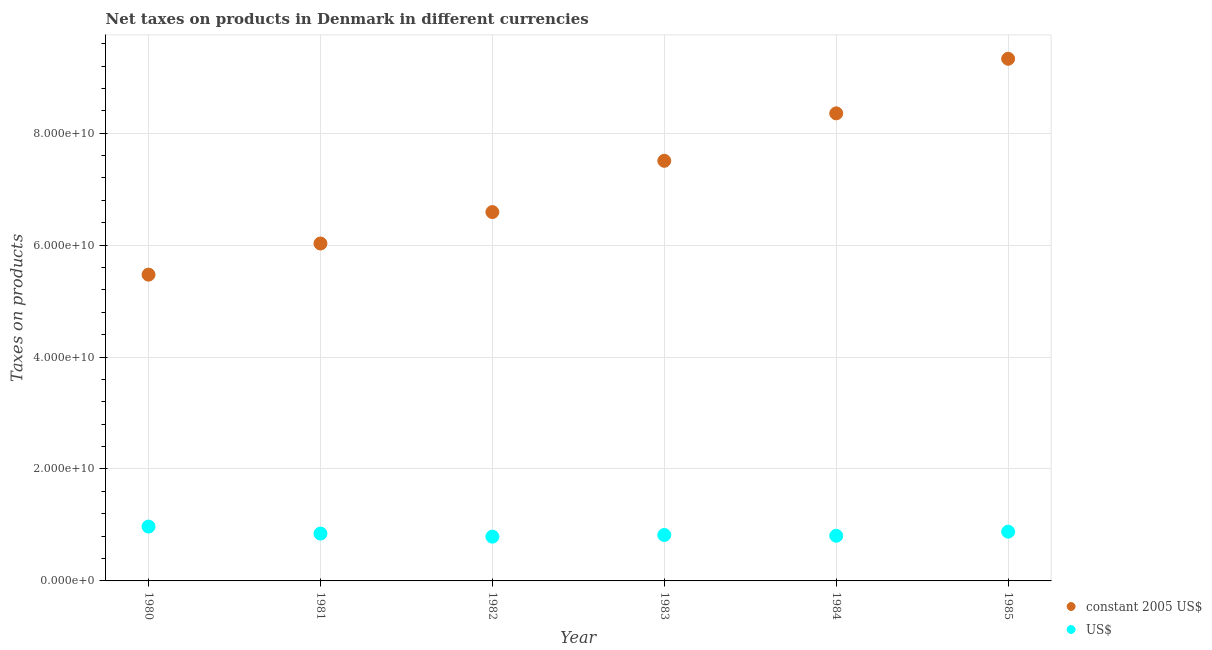How many different coloured dotlines are there?
Ensure brevity in your answer.  2. What is the net taxes in constant 2005 us$ in 1981?
Provide a succinct answer. 6.03e+1. Across all years, what is the maximum net taxes in us$?
Your answer should be very brief. 9.71e+09. Across all years, what is the minimum net taxes in constant 2005 us$?
Make the answer very short. 5.47e+1. In which year was the net taxes in constant 2005 us$ minimum?
Ensure brevity in your answer.  1980. What is the total net taxes in us$ in the graph?
Provide a succinct answer. 5.12e+1. What is the difference between the net taxes in constant 2005 us$ in 1980 and that in 1982?
Offer a very short reply. -1.12e+1. What is the difference between the net taxes in us$ in 1982 and the net taxes in constant 2005 us$ in 1983?
Keep it short and to the point. -6.72e+1. What is the average net taxes in constant 2005 us$ per year?
Ensure brevity in your answer.  7.21e+1. In the year 1985, what is the difference between the net taxes in us$ and net taxes in constant 2005 us$?
Your response must be concise. -8.45e+1. What is the ratio of the net taxes in constant 2005 us$ in 1980 to that in 1981?
Offer a very short reply. 0.91. Is the difference between the net taxes in constant 2005 us$ in 1983 and 1985 greater than the difference between the net taxes in us$ in 1983 and 1985?
Your response must be concise. No. What is the difference between the highest and the second highest net taxes in constant 2005 us$?
Make the answer very short. 9.75e+09. What is the difference between the highest and the lowest net taxes in constant 2005 us$?
Offer a very short reply. 3.86e+1. Is the sum of the net taxes in constant 2005 us$ in 1981 and 1983 greater than the maximum net taxes in us$ across all years?
Your answer should be very brief. Yes. Is the net taxes in constant 2005 us$ strictly greater than the net taxes in us$ over the years?
Provide a short and direct response. Yes. How many years are there in the graph?
Keep it short and to the point. 6. What is the difference between two consecutive major ticks on the Y-axis?
Offer a very short reply. 2.00e+1. Are the values on the major ticks of Y-axis written in scientific E-notation?
Give a very brief answer. Yes. Does the graph contain any zero values?
Your answer should be compact. No. How many legend labels are there?
Make the answer very short. 2. How are the legend labels stacked?
Offer a terse response. Vertical. What is the title of the graph?
Offer a terse response. Net taxes on products in Denmark in different currencies. Does "Urban agglomerations" appear as one of the legend labels in the graph?
Your answer should be very brief. No. What is the label or title of the Y-axis?
Your answer should be very brief. Taxes on products. What is the Taxes on products of constant 2005 US$ in 1980?
Keep it short and to the point. 5.47e+1. What is the Taxes on products in US$ in 1980?
Keep it short and to the point. 9.71e+09. What is the Taxes on products in constant 2005 US$ in 1981?
Ensure brevity in your answer.  6.03e+1. What is the Taxes on products in US$ in 1981?
Provide a succinct answer. 8.46e+09. What is the Taxes on products in constant 2005 US$ in 1982?
Offer a very short reply. 6.59e+1. What is the Taxes on products of US$ in 1982?
Your answer should be compact. 7.91e+09. What is the Taxes on products in constant 2005 US$ in 1983?
Ensure brevity in your answer.  7.51e+1. What is the Taxes on products of US$ in 1983?
Your answer should be very brief. 8.21e+09. What is the Taxes on products of constant 2005 US$ in 1984?
Keep it short and to the point. 8.35e+1. What is the Taxes on products of US$ in 1984?
Keep it short and to the point. 8.07e+09. What is the Taxes on products in constant 2005 US$ in 1985?
Ensure brevity in your answer.  9.33e+1. What is the Taxes on products in US$ in 1985?
Ensure brevity in your answer.  8.80e+09. Across all years, what is the maximum Taxes on products in constant 2005 US$?
Your response must be concise. 9.33e+1. Across all years, what is the maximum Taxes on products of US$?
Keep it short and to the point. 9.71e+09. Across all years, what is the minimum Taxes on products in constant 2005 US$?
Offer a terse response. 5.47e+1. Across all years, what is the minimum Taxes on products in US$?
Make the answer very short. 7.91e+09. What is the total Taxes on products of constant 2005 US$ in the graph?
Your answer should be very brief. 4.33e+11. What is the total Taxes on products in US$ in the graph?
Offer a terse response. 5.12e+1. What is the difference between the Taxes on products in constant 2005 US$ in 1980 and that in 1981?
Give a very brief answer. -5.56e+09. What is the difference between the Taxes on products of US$ in 1980 and that in 1981?
Provide a short and direct response. 1.25e+09. What is the difference between the Taxes on products of constant 2005 US$ in 1980 and that in 1982?
Make the answer very short. -1.12e+1. What is the difference between the Taxes on products of US$ in 1980 and that in 1982?
Your answer should be compact. 1.80e+09. What is the difference between the Taxes on products of constant 2005 US$ in 1980 and that in 1983?
Your answer should be compact. -2.03e+1. What is the difference between the Taxes on products in US$ in 1980 and that in 1983?
Offer a very short reply. 1.50e+09. What is the difference between the Taxes on products of constant 2005 US$ in 1980 and that in 1984?
Make the answer very short. -2.88e+1. What is the difference between the Taxes on products in US$ in 1980 and that in 1984?
Make the answer very short. 1.64e+09. What is the difference between the Taxes on products in constant 2005 US$ in 1980 and that in 1985?
Make the answer very short. -3.86e+1. What is the difference between the Taxes on products in US$ in 1980 and that in 1985?
Keep it short and to the point. 9.06e+08. What is the difference between the Taxes on products of constant 2005 US$ in 1981 and that in 1982?
Your answer should be very brief. -5.62e+09. What is the difference between the Taxes on products in US$ in 1981 and that in 1982?
Offer a terse response. 5.54e+08. What is the difference between the Taxes on products of constant 2005 US$ in 1981 and that in 1983?
Provide a succinct answer. -1.48e+1. What is the difference between the Taxes on products in US$ in 1981 and that in 1983?
Make the answer very short. 2.55e+08. What is the difference between the Taxes on products of constant 2005 US$ in 1981 and that in 1984?
Your answer should be compact. -2.33e+1. What is the difference between the Taxes on products of US$ in 1981 and that in 1984?
Ensure brevity in your answer.  3.97e+08. What is the difference between the Taxes on products in constant 2005 US$ in 1981 and that in 1985?
Give a very brief answer. -3.30e+1. What is the difference between the Taxes on products of US$ in 1981 and that in 1985?
Your answer should be compact. -3.41e+08. What is the difference between the Taxes on products in constant 2005 US$ in 1982 and that in 1983?
Offer a terse response. -9.16e+09. What is the difference between the Taxes on products in US$ in 1982 and that in 1983?
Provide a short and direct response. -2.99e+08. What is the difference between the Taxes on products of constant 2005 US$ in 1982 and that in 1984?
Provide a short and direct response. -1.76e+1. What is the difference between the Taxes on products of US$ in 1982 and that in 1984?
Your answer should be very brief. -1.57e+08. What is the difference between the Taxes on products of constant 2005 US$ in 1982 and that in 1985?
Your answer should be compact. -2.74e+1. What is the difference between the Taxes on products of US$ in 1982 and that in 1985?
Keep it short and to the point. -8.95e+08. What is the difference between the Taxes on products in constant 2005 US$ in 1983 and that in 1984?
Ensure brevity in your answer.  -8.48e+09. What is the difference between the Taxes on products of US$ in 1983 and that in 1984?
Your response must be concise. 1.42e+08. What is the difference between the Taxes on products of constant 2005 US$ in 1983 and that in 1985?
Give a very brief answer. -1.82e+1. What is the difference between the Taxes on products in US$ in 1983 and that in 1985?
Your response must be concise. -5.96e+08. What is the difference between the Taxes on products of constant 2005 US$ in 1984 and that in 1985?
Give a very brief answer. -9.75e+09. What is the difference between the Taxes on products in US$ in 1984 and that in 1985?
Your response must be concise. -7.38e+08. What is the difference between the Taxes on products in constant 2005 US$ in 1980 and the Taxes on products in US$ in 1981?
Offer a terse response. 4.63e+1. What is the difference between the Taxes on products in constant 2005 US$ in 1980 and the Taxes on products in US$ in 1982?
Your answer should be compact. 4.68e+1. What is the difference between the Taxes on products of constant 2005 US$ in 1980 and the Taxes on products of US$ in 1983?
Offer a very short reply. 4.65e+1. What is the difference between the Taxes on products of constant 2005 US$ in 1980 and the Taxes on products of US$ in 1984?
Ensure brevity in your answer.  4.67e+1. What is the difference between the Taxes on products of constant 2005 US$ in 1980 and the Taxes on products of US$ in 1985?
Your answer should be compact. 4.59e+1. What is the difference between the Taxes on products of constant 2005 US$ in 1981 and the Taxes on products of US$ in 1982?
Keep it short and to the point. 5.24e+1. What is the difference between the Taxes on products of constant 2005 US$ in 1981 and the Taxes on products of US$ in 1983?
Your response must be concise. 5.21e+1. What is the difference between the Taxes on products in constant 2005 US$ in 1981 and the Taxes on products in US$ in 1984?
Provide a short and direct response. 5.22e+1. What is the difference between the Taxes on products of constant 2005 US$ in 1981 and the Taxes on products of US$ in 1985?
Your answer should be very brief. 5.15e+1. What is the difference between the Taxes on products in constant 2005 US$ in 1982 and the Taxes on products in US$ in 1983?
Provide a succinct answer. 5.77e+1. What is the difference between the Taxes on products of constant 2005 US$ in 1982 and the Taxes on products of US$ in 1984?
Your answer should be compact. 5.78e+1. What is the difference between the Taxes on products of constant 2005 US$ in 1982 and the Taxes on products of US$ in 1985?
Ensure brevity in your answer.  5.71e+1. What is the difference between the Taxes on products in constant 2005 US$ in 1983 and the Taxes on products in US$ in 1984?
Keep it short and to the point. 6.70e+1. What is the difference between the Taxes on products of constant 2005 US$ in 1983 and the Taxes on products of US$ in 1985?
Give a very brief answer. 6.63e+1. What is the difference between the Taxes on products of constant 2005 US$ in 1984 and the Taxes on products of US$ in 1985?
Keep it short and to the point. 7.47e+1. What is the average Taxes on products in constant 2005 US$ per year?
Keep it short and to the point. 7.21e+1. What is the average Taxes on products in US$ per year?
Offer a terse response. 8.53e+09. In the year 1980, what is the difference between the Taxes on products of constant 2005 US$ and Taxes on products of US$?
Give a very brief answer. 4.50e+1. In the year 1981, what is the difference between the Taxes on products of constant 2005 US$ and Taxes on products of US$?
Offer a terse response. 5.18e+1. In the year 1982, what is the difference between the Taxes on products of constant 2005 US$ and Taxes on products of US$?
Give a very brief answer. 5.80e+1. In the year 1983, what is the difference between the Taxes on products of constant 2005 US$ and Taxes on products of US$?
Keep it short and to the point. 6.69e+1. In the year 1984, what is the difference between the Taxes on products in constant 2005 US$ and Taxes on products in US$?
Offer a terse response. 7.55e+1. In the year 1985, what is the difference between the Taxes on products in constant 2005 US$ and Taxes on products in US$?
Your response must be concise. 8.45e+1. What is the ratio of the Taxes on products of constant 2005 US$ in 1980 to that in 1981?
Offer a terse response. 0.91. What is the ratio of the Taxes on products in US$ in 1980 to that in 1981?
Your answer should be compact. 1.15. What is the ratio of the Taxes on products of constant 2005 US$ in 1980 to that in 1982?
Your answer should be very brief. 0.83. What is the ratio of the Taxes on products of US$ in 1980 to that in 1982?
Offer a very short reply. 1.23. What is the ratio of the Taxes on products of constant 2005 US$ in 1980 to that in 1983?
Provide a succinct answer. 0.73. What is the ratio of the Taxes on products of US$ in 1980 to that in 1983?
Provide a succinct answer. 1.18. What is the ratio of the Taxes on products in constant 2005 US$ in 1980 to that in 1984?
Provide a short and direct response. 0.66. What is the ratio of the Taxes on products of US$ in 1980 to that in 1984?
Provide a short and direct response. 1.2. What is the ratio of the Taxes on products of constant 2005 US$ in 1980 to that in 1985?
Give a very brief answer. 0.59. What is the ratio of the Taxes on products in US$ in 1980 to that in 1985?
Provide a short and direct response. 1.1. What is the ratio of the Taxes on products of constant 2005 US$ in 1981 to that in 1982?
Ensure brevity in your answer.  0.91. What is the ratio of the Taxes on products in US$ in 1981 to that in 1982?
Give a very brief answer. 1.07. What is the ratio of the Taxes on products of constant 2005 US$ in 1981 to that in 1983?
Offer a very short reply. 0.8. What is the ratio of the Taxes on products in US$ in 1981 to that in 1983?
Your answer should be very brief. 1.03. What is the ratio of the Taxes on products of constant 2005 US$ in 1981 to that in 1984?
Make the answer very short. 0.72. What is the ratio of the Taxes on products in US$ in 1981 to that in 1984?
Offer a terse response. 1.05. What is the ratio of the Taxes on products of constant 2005 US$ in 1981 to that in 1985?
Provide a short and direct response. 0.65. What is the ratio of the Taxes on products in US$ in 1981 to that in 1985?
Offer a very short reply. 0.96. What is the ratio of the Taxes on products of constant 2005 US$ in 1982 to that in 1983?
Make the answer very short. 0.88. What is the ratio of the Taxes on products in US$ in 1982 to that in 1983?
Offer a very short reply. 0.96. What is the ratio of the Taxes on products of constant 2005 US$ in 1982 to that in 1984?
Ensure brevity in your answer.  0.79. What is the ratio of the Taxes on products in US$ in 1982 to that in 1984?
Provide a short and direct response. 0.98. What is the ratio of the Taxes on products in constant 2005 US$ in 1982 to that in 1985?
Provide a short and direct response. 0.71. What is the ratio of the Taxes on products in US$ in 1982 to that in 1985?
Give a very brief answer. 0.9. What is the ratio of the Taxes on products of constant 2005 US$ in 1983 to that in 1984?
Keep it short and to the point. 0.9. What is the ratio of the Taxes on products of US$ in 1983 to that in 1984?
Offer a very short reply. 1.02. What is the ratio of the Taxes on products of constant 2005 US$ in 1983 to that in 1985?
Your answer should be compact. 0.8. What is the ratio of the Taxes on products of US$ in 1983 to that in 1985?
Offer a very short reply. 0.93. What is the ratio of the Taxes on products of constant 2005 US$ in 1984 to that in 1985?
Offer a terse response. 0.9. What is the ratio of the Taxes on products in US$ in 1984 to that in 1985?
Your response must be concise. 0.92. What is the difference between the highest and the second highest Taxes on products of constant 2005 US$?
Provide a succinct answer. 9.75e+09. What is the difference between the highest and the second highest Taxes on products of US$?
Keep it short and to the point. 9.06e+08. What is the difference between the highest and the lowest Taxes on products in constant 2005 US$?
Ensure brevity in your answer.  3.86e+1. What is the difference between the highest and the lowest Taxes on products of US$?
Your answer should be compact. 1.80e+09. 